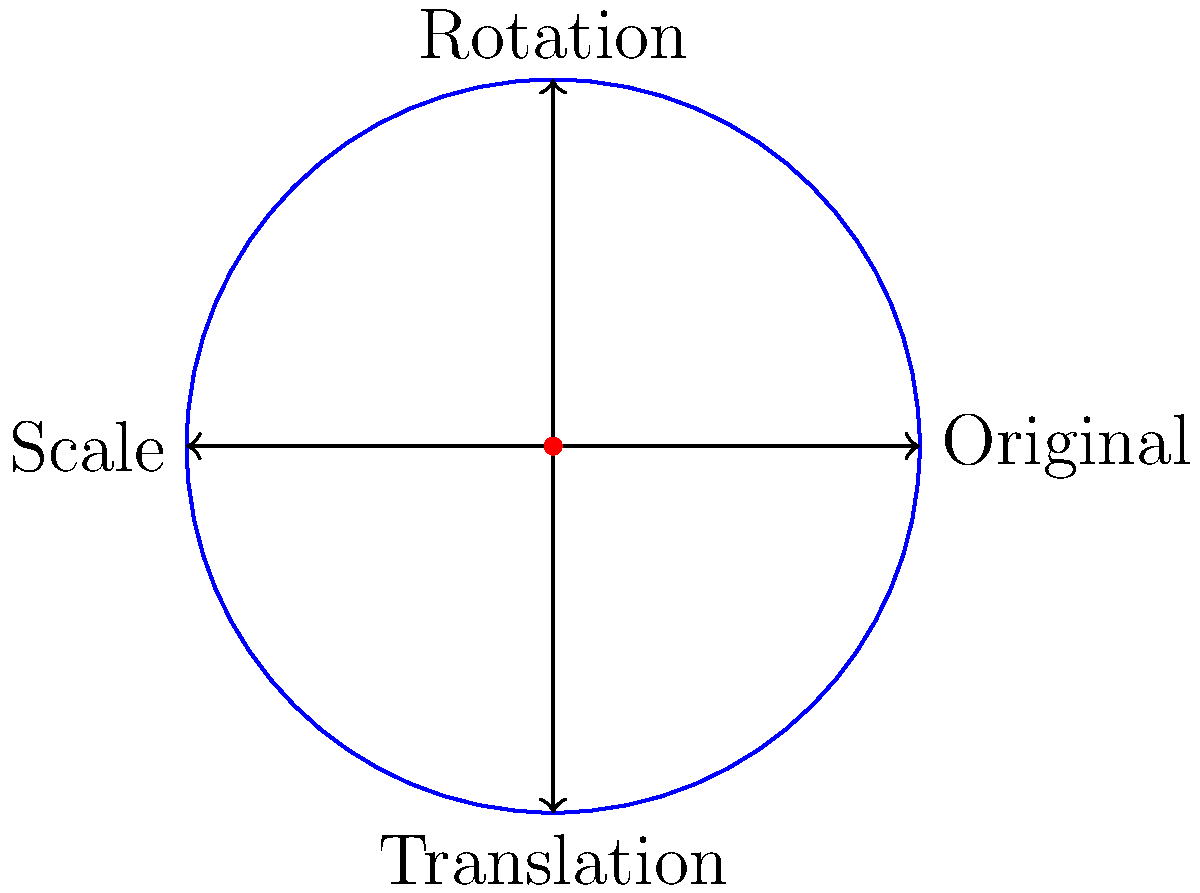In a mobile game, you need to create a complex particle effect for a magical spell. The effect involves rotating a circular particle around its center, scaling it, and then translating it across the screen. Given that the initial particle is at coordinates (2, 3) with a radius of 5 pixels, rotate it 45° clockwise, scale it by a factor of 1.5, and then translate it 10 pixels right and 7 pixels up. What are the final coordinates of the particle's center and its new radius? Let's break this down step by step:

1. Initial state:
   - Coordinates: (2, 3)
   - Radius: 5 pixels

2. Rotation by 45° clockwise:
   - Rotation doesn't change the coordinates of the center or the radius
   - Coordinates remain (2, 3)
   - Radius remains 5 pixels

3. Scaling by a factor of 1.5:
   - Scaling doesn't change the coordinates of the center
   - Coordinates remain (2, 3)
   - New radius = 5 * 1.5 = 7.5 pixels

4. Translation 10 pixels right and 7 pixels up:
   - New x-coordinate = 2 + 10 = 12
   - New y-coordinate = 3 + 7 = 10
   - Final coordinates: (12, 10)
   - Radius remains 7.5 pixels (translation doesn't affect radius)

Therefore, after applying all transformations:
- The final coordinates of the particle's center are (12, 10)
- The new radius is 7.5 pixels
Answer: (12, 10), 7.5 pixels 